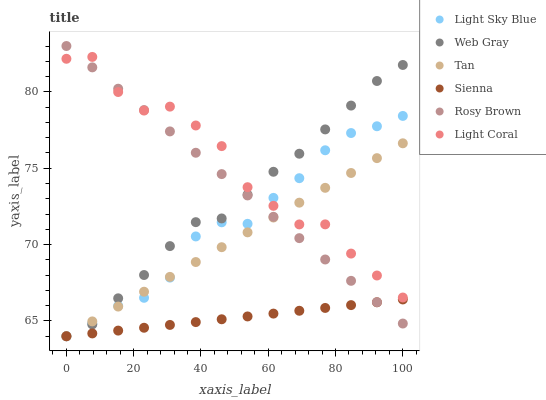Does Sienna have the minimum area under the curve?
Answer yes or no. Yes. Does Light Coral have the maximum area under the curve?
Answer yes or no. Yes. Does Web Gray have the minimum area under the curve?
Answer yes or no. No. Does Web Gray have the maximum area under the curve?
Answer yes or no. No. Is Rosy Brown the smoothest?
Answer yes or no. Yes. Is Light Coral the roughest?
Answer yes or no. Yes. Is Web Gray the smoothest?
Answer yes or no. No. Is Web Gray the roughest?
Answer yes or no. No. Does Web Gray have the lowest value?
Answer yes or no. Yes. Does Rosy Brown have the lowest value?
Answer yes or no. No. Does Rosy Brown have the highest value?
Answer yes or no. Yes. Does Web Gray have the highest value?
Answer yes or no. No. Is Sienna less than Light Coral?
Answer yes or no. Yes. Is Light Coral greater than Sienna?
Answer yes or no. Yes. Does Sienna intersect Light Sky Blue?
Answer yes or no. Yes. Is Sienna less than Light Sky Blue?
Answer yes or no. No. Is Sienna greater than Light Sky Blue?
Answer yes or no. No. Does Sienna intersect Light Coral?
Answer yes or no. No. 